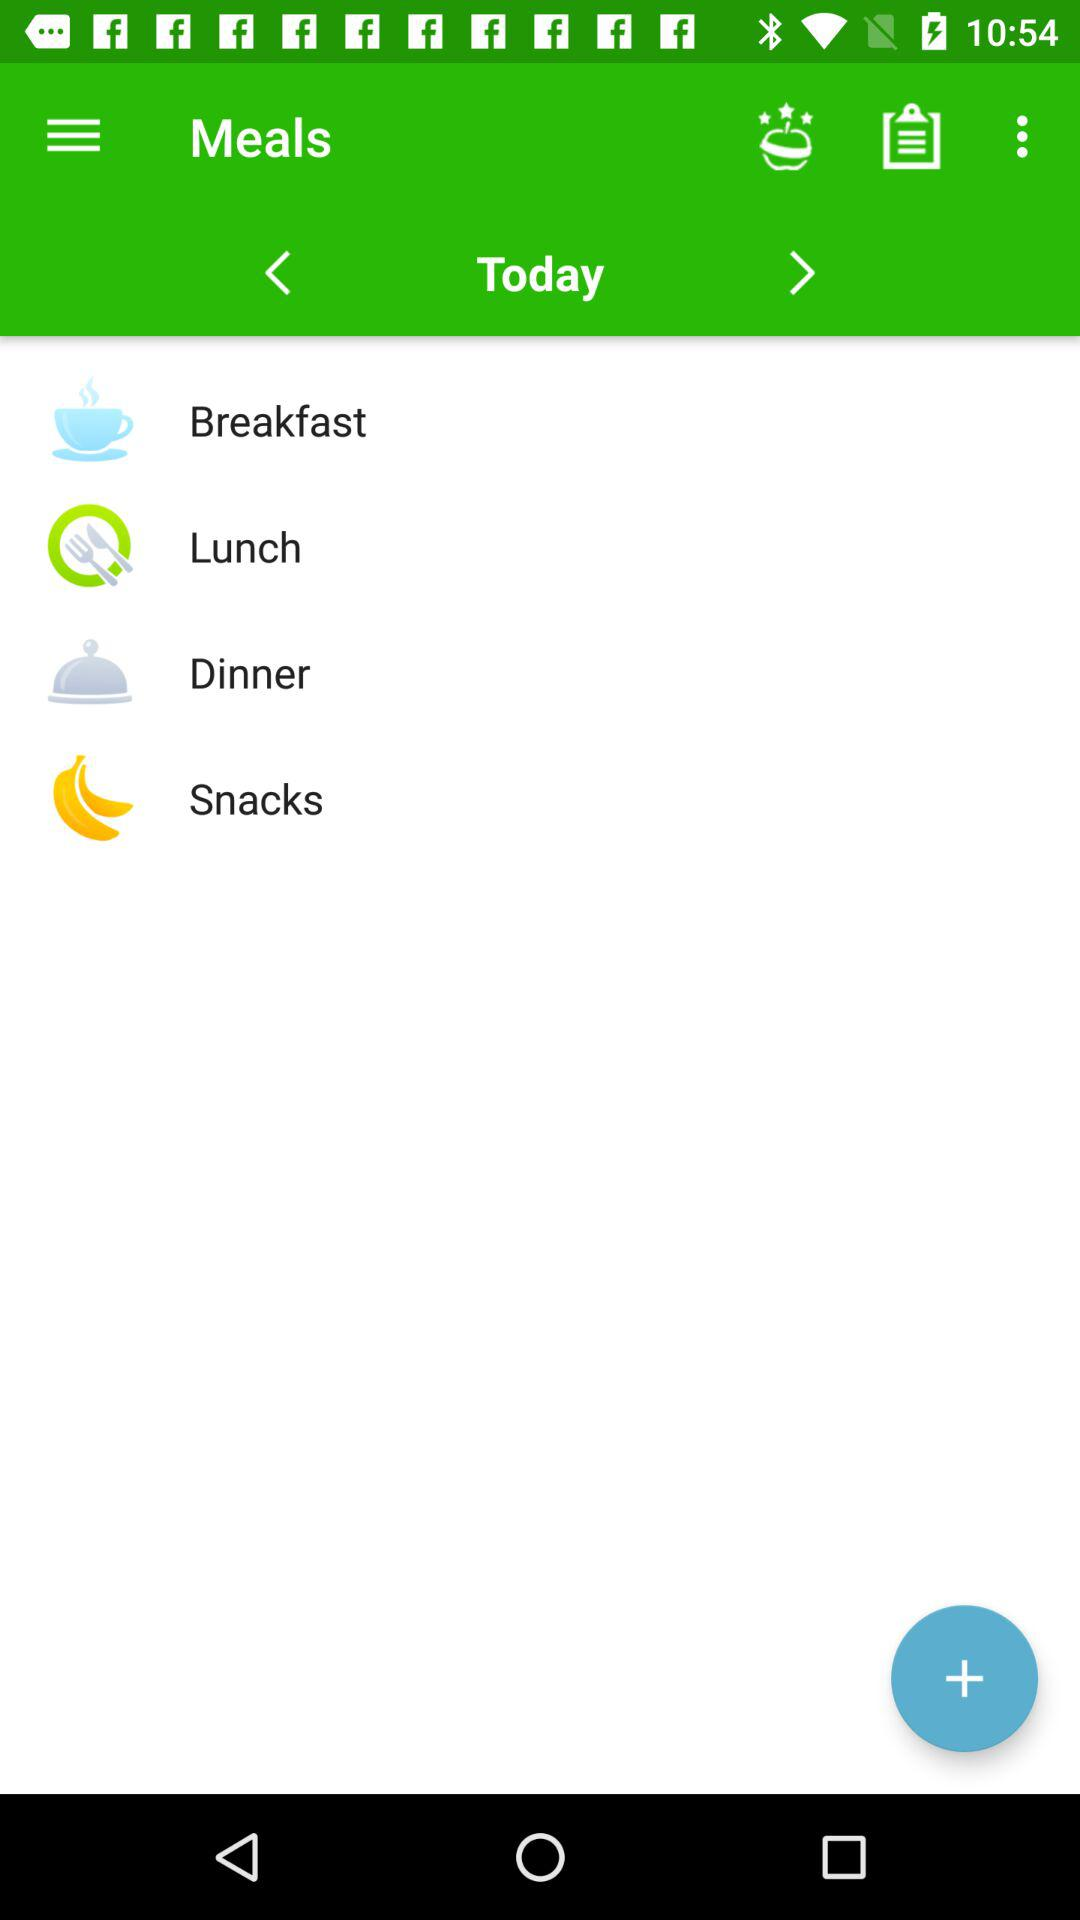What are the different types of meals? The different types of meals are "Breakfast", "Lunch", "Dinner", and "Snacks". 